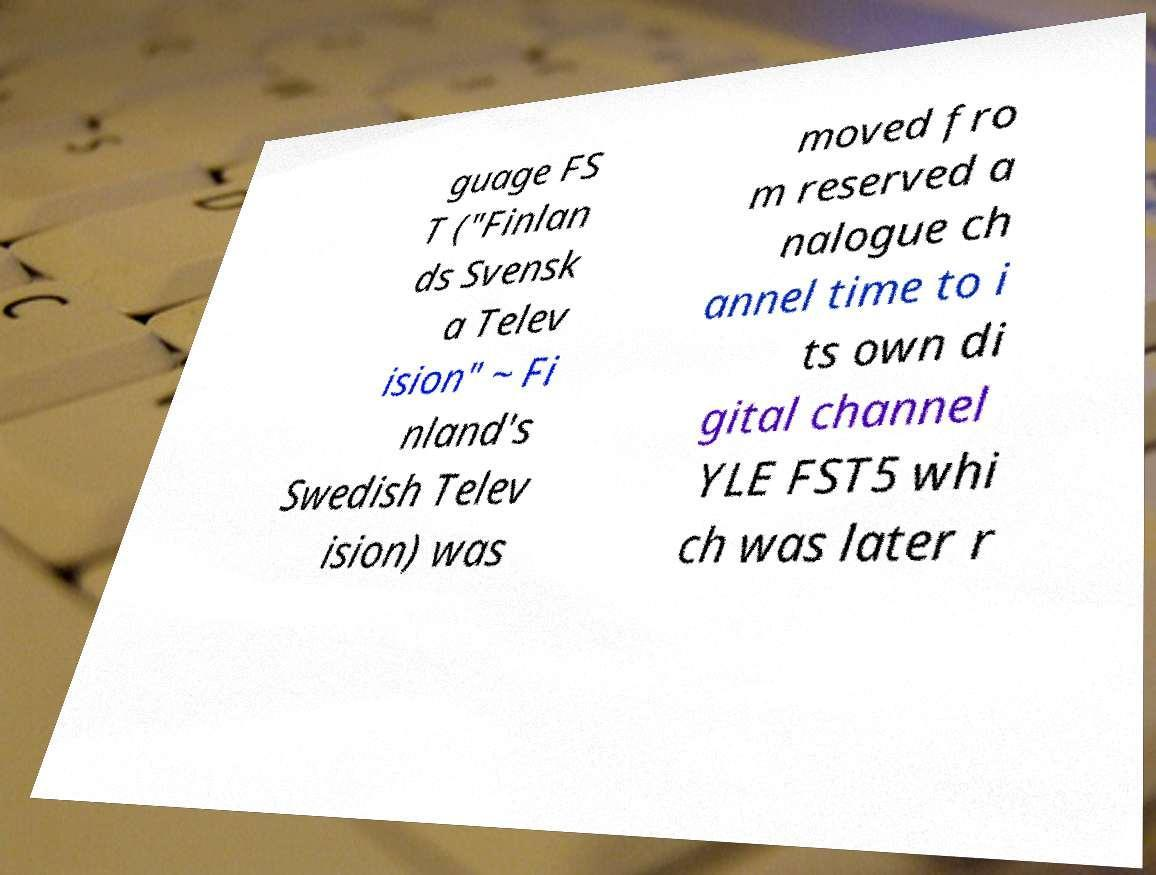Please read and relay the text visible in this image. What does it say? guage FS T ("Finlan ds Svensk a Telev ision" ~ Fi nland's Swedish Telev ision) was moved fro m reserved a nalogue ch annel time to i ts own di gital channel YLE FST5 whi ch was later r 